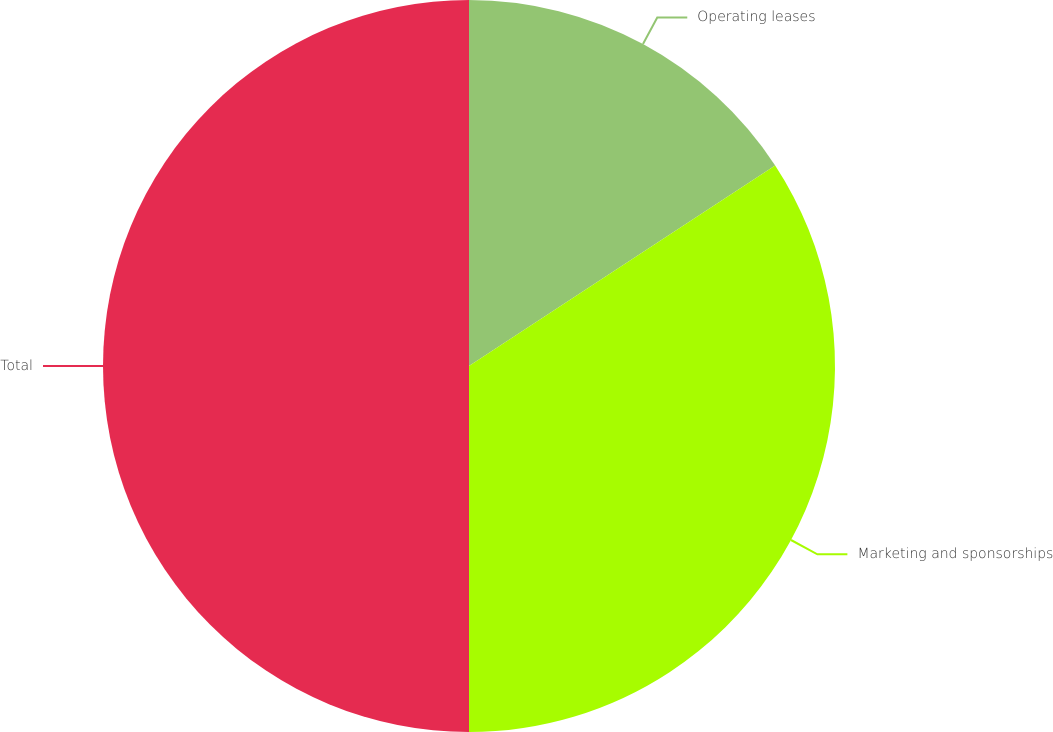Convert chart to OTSL. <chart><loc_0><loc_0><loc_500><loc_500><pie_chart><fcel>Operating leases<fcel>Marketing and sponsorships<fcel>Total<nl><fcel>15.77%<fcel>34.23%<fcel>50.0%<nl></chart> 